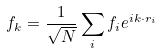Convert formula to latex. <formula><loc_0><loc_0><loc_500><loc_500>f _ { k } = \frac { 1 } { \sqrt { N } } \sum _ { i } f _ { i } e ^ { i { k } \cdot { r } _ { i } }</formula> 